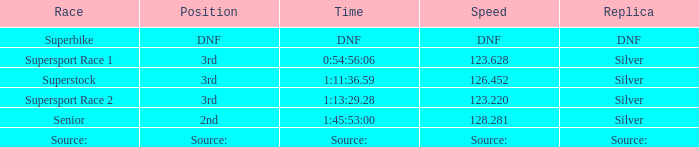220? 3rd. Parse the table in full. {'header': ['Race', 'Position', 'Time', 'Speed', 'Replica'], 'rows': [['Superbike', 'DNF', 'DNF', 'DNF', 'DNF'], ['Supersport Race 1', '3rd', '0:54:56:06', '123.628', 'Silver'], ['Superstock', '3rd', '1:11:36.59', '126.452', 'Silver'], ['Supersport Race 2', '3rd', '1:13:29.28', '123.220', 'Silver'], ['Senior', '2nd', '1:45:53:00', '128.281', 'Silver'], ['Source:', 'Source:', 'Source:', 'Source:', 'Source:']]} 